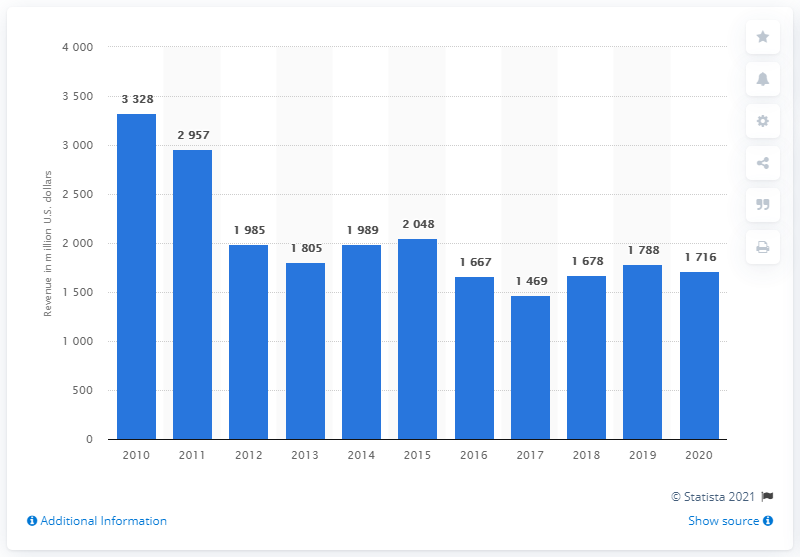Specify some key components in this picture. BP's corporate segment generated $171.6 million in revenue in 2022. 